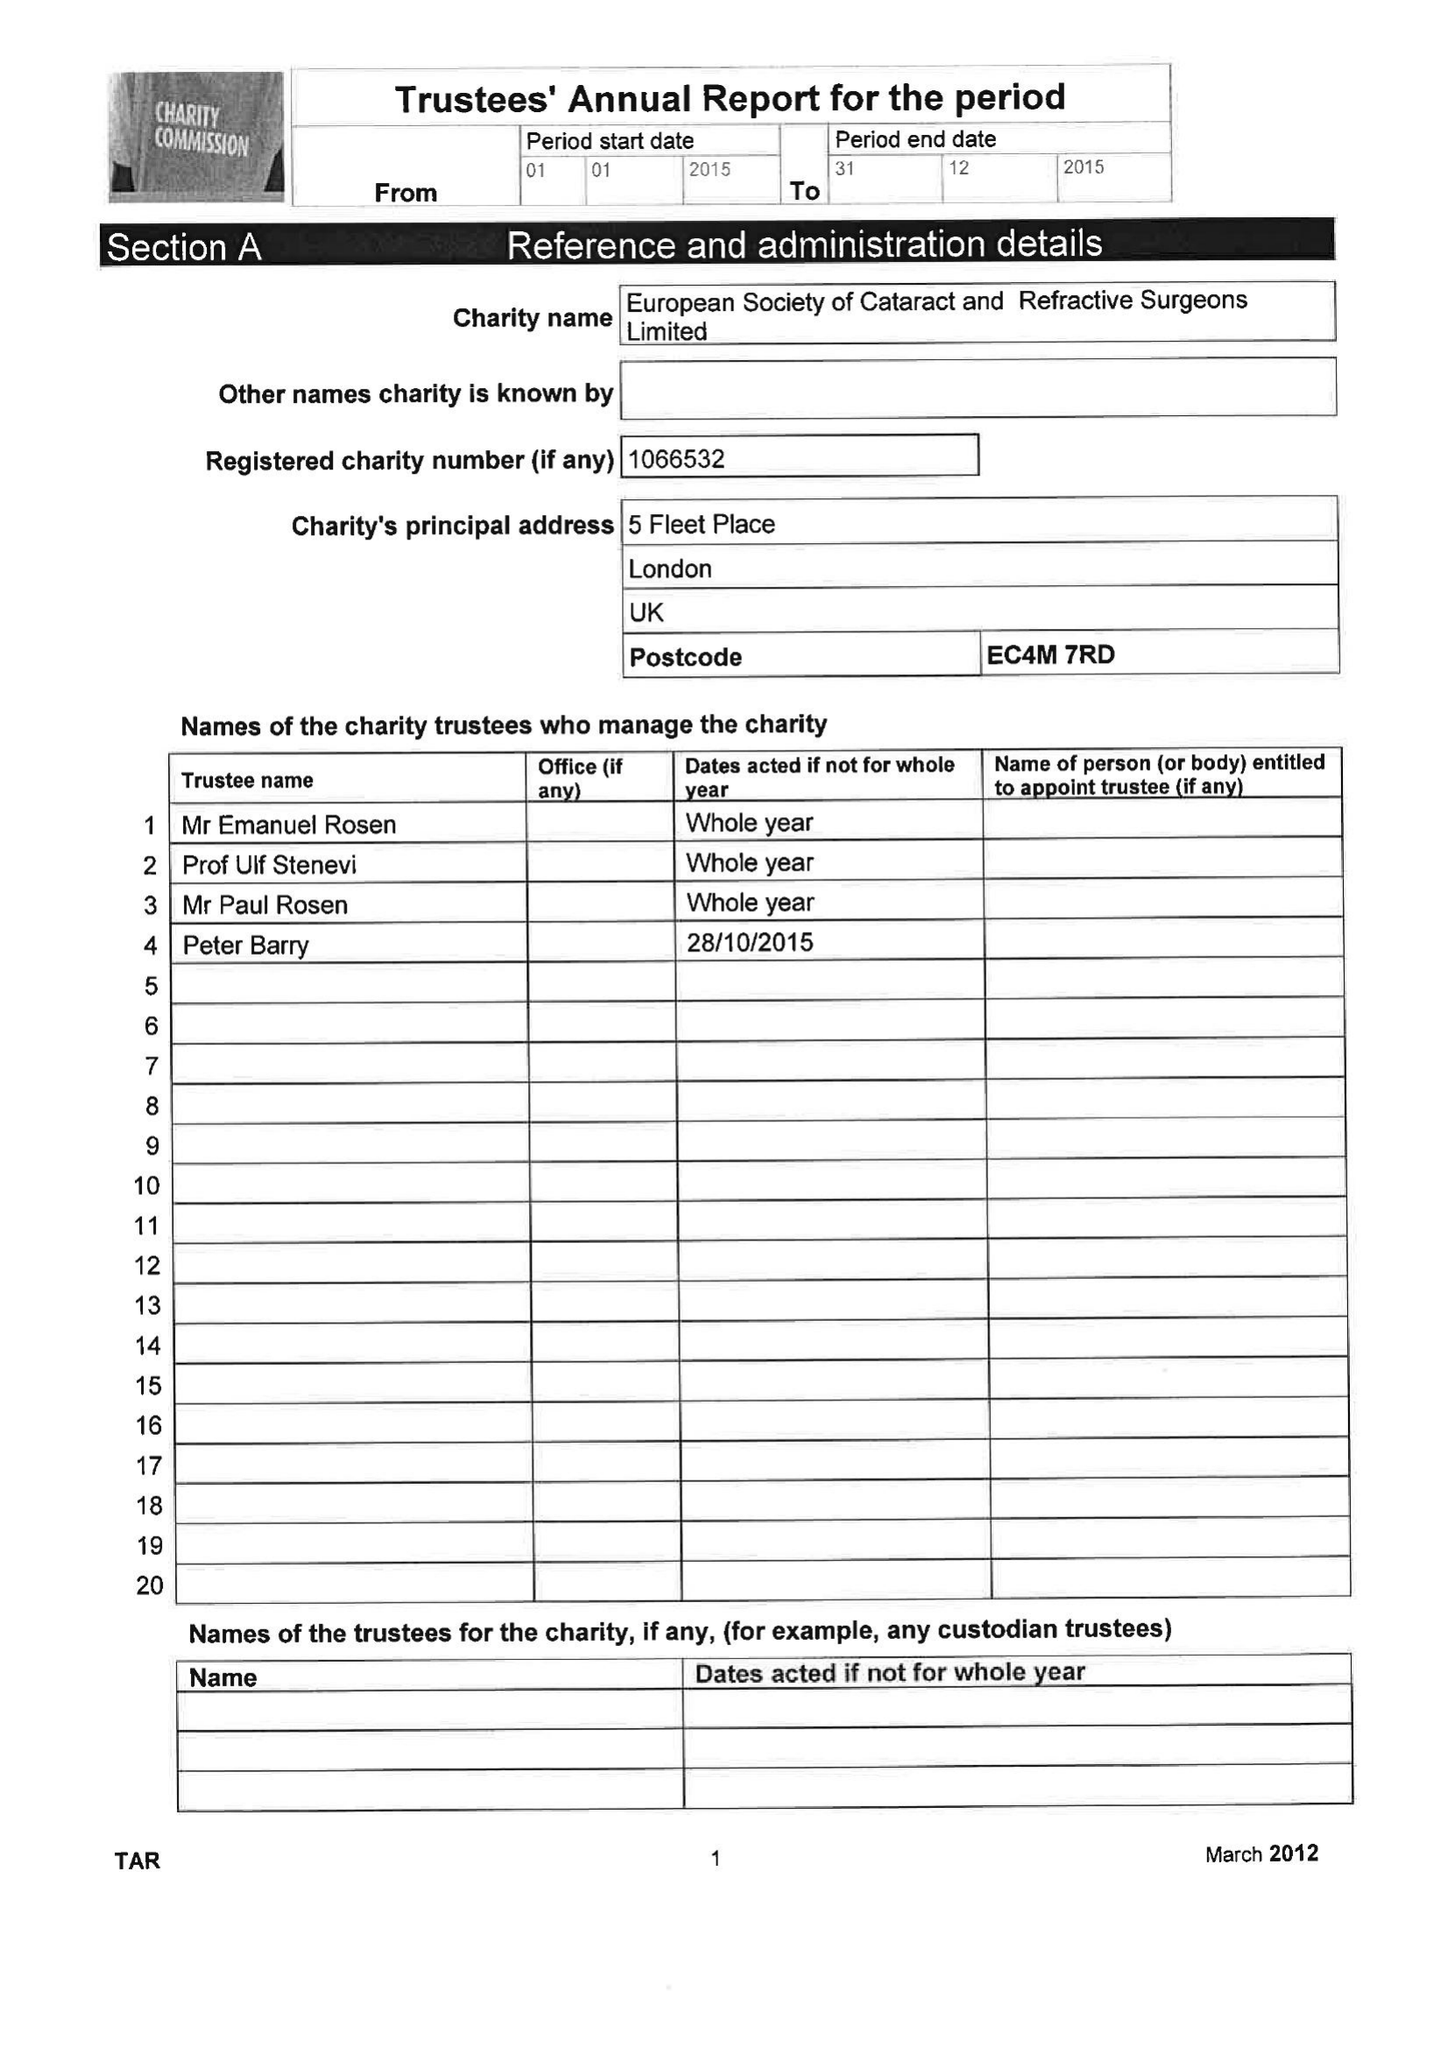What is the value for the income_annually_in_british_pounds?
Answer the question using a single word or phrase. 3063652.00 